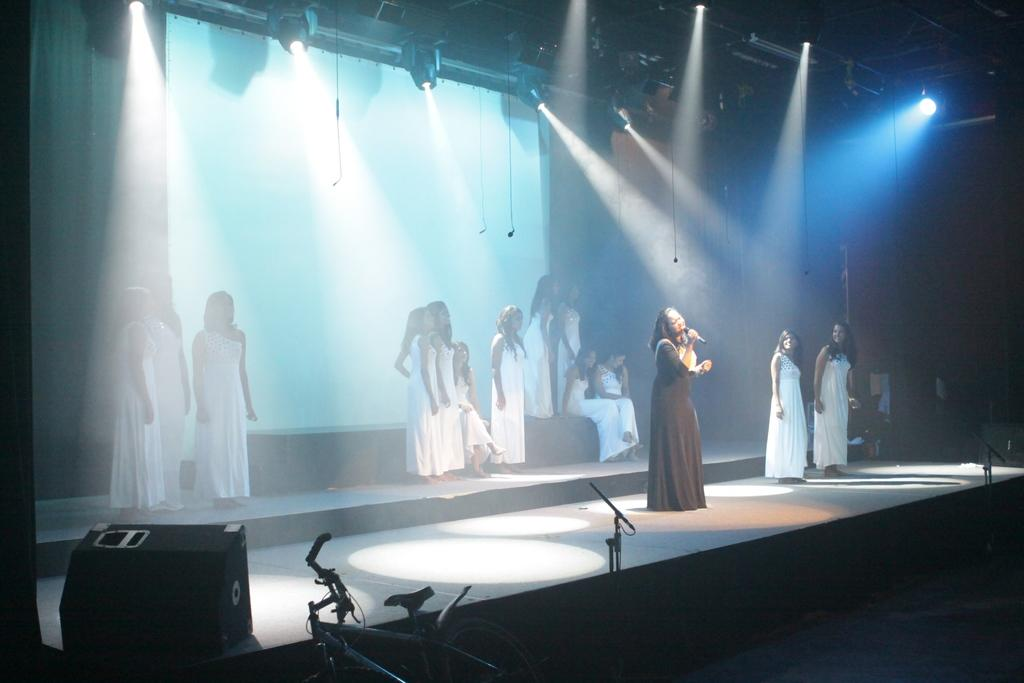What is the main feature of the image? There is a stage in the image. What is happening on the stage? People are performing on the stage. What can be seen in the background of the stage? There is a curtain in the background. What is illuminating the stage? Lights are visible at the top of the image. What type of pickle is being used as a prop by the performers on the stage? There is no pickle present in the image, and therefore it cannot be used as a prop by the performers. 